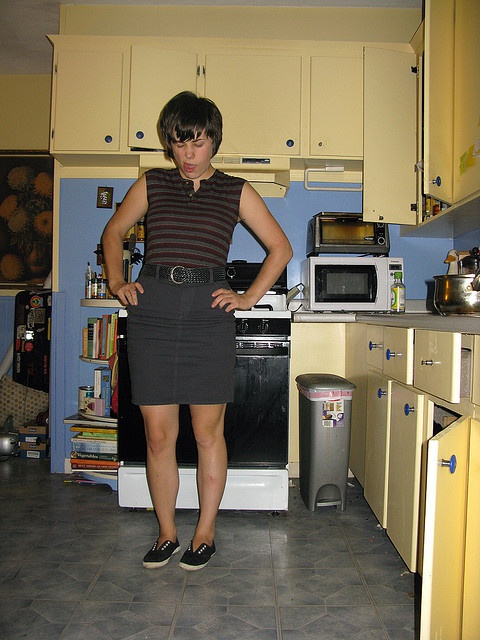Describe the objects in this image and their specific colors. I can see people in maroon, black, gray, and tan tones, oven in maroon, black, lightgray, gray, and darkgray tones, microwave in maroon, black, darkgray, gray, and lightgray tones, oven in maroon, black, olive, and gray tones, and bowl in maroon, black, white, and gray tones in this image. 